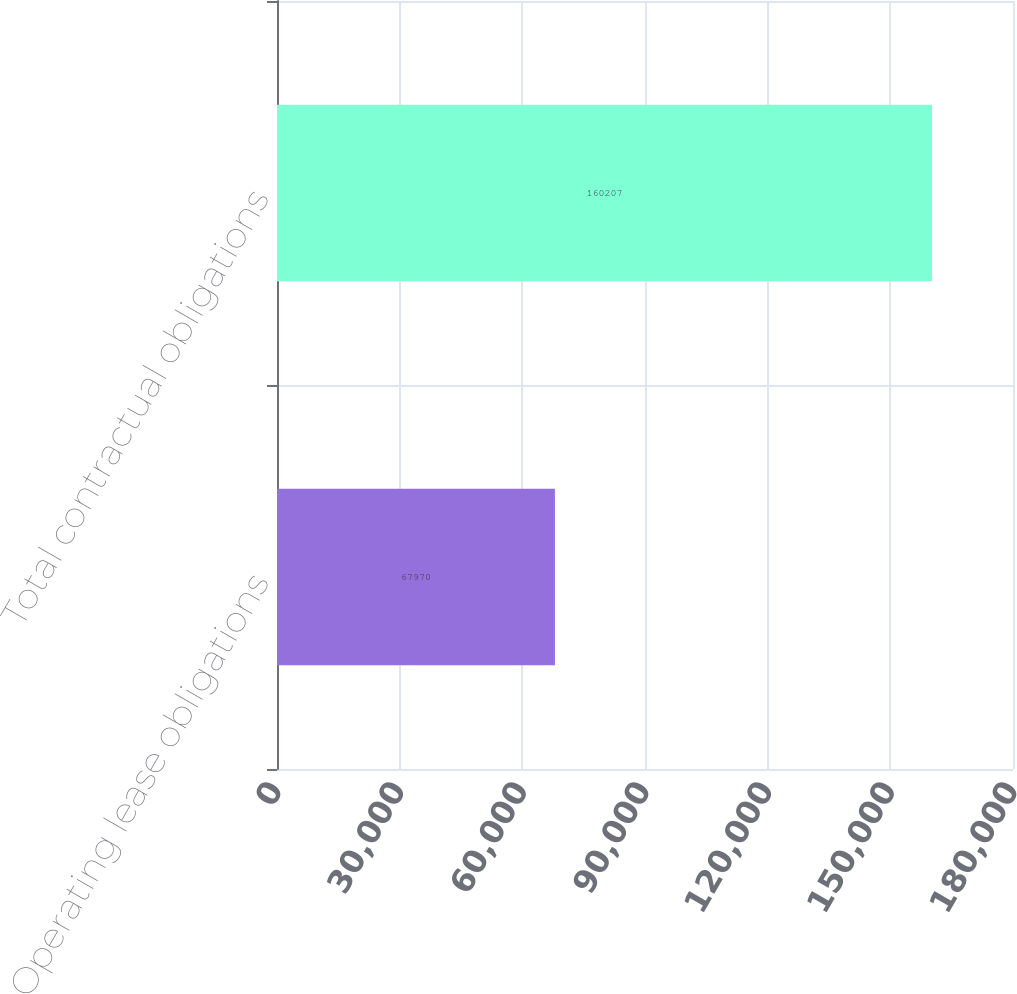Convert chart. <chart><loc_0><loc_0><loc_500><loc_500><bar_chart><fcel>Operating lease obligations<fcel>Total contractual obligations<nl><fcel>67970<fcel>160207<nl></chart> 